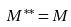Convert formula to latex. <formula><loc_0><loc_0><loc_500><loc_500>M ^ { \ast \ast } = M</formula> 